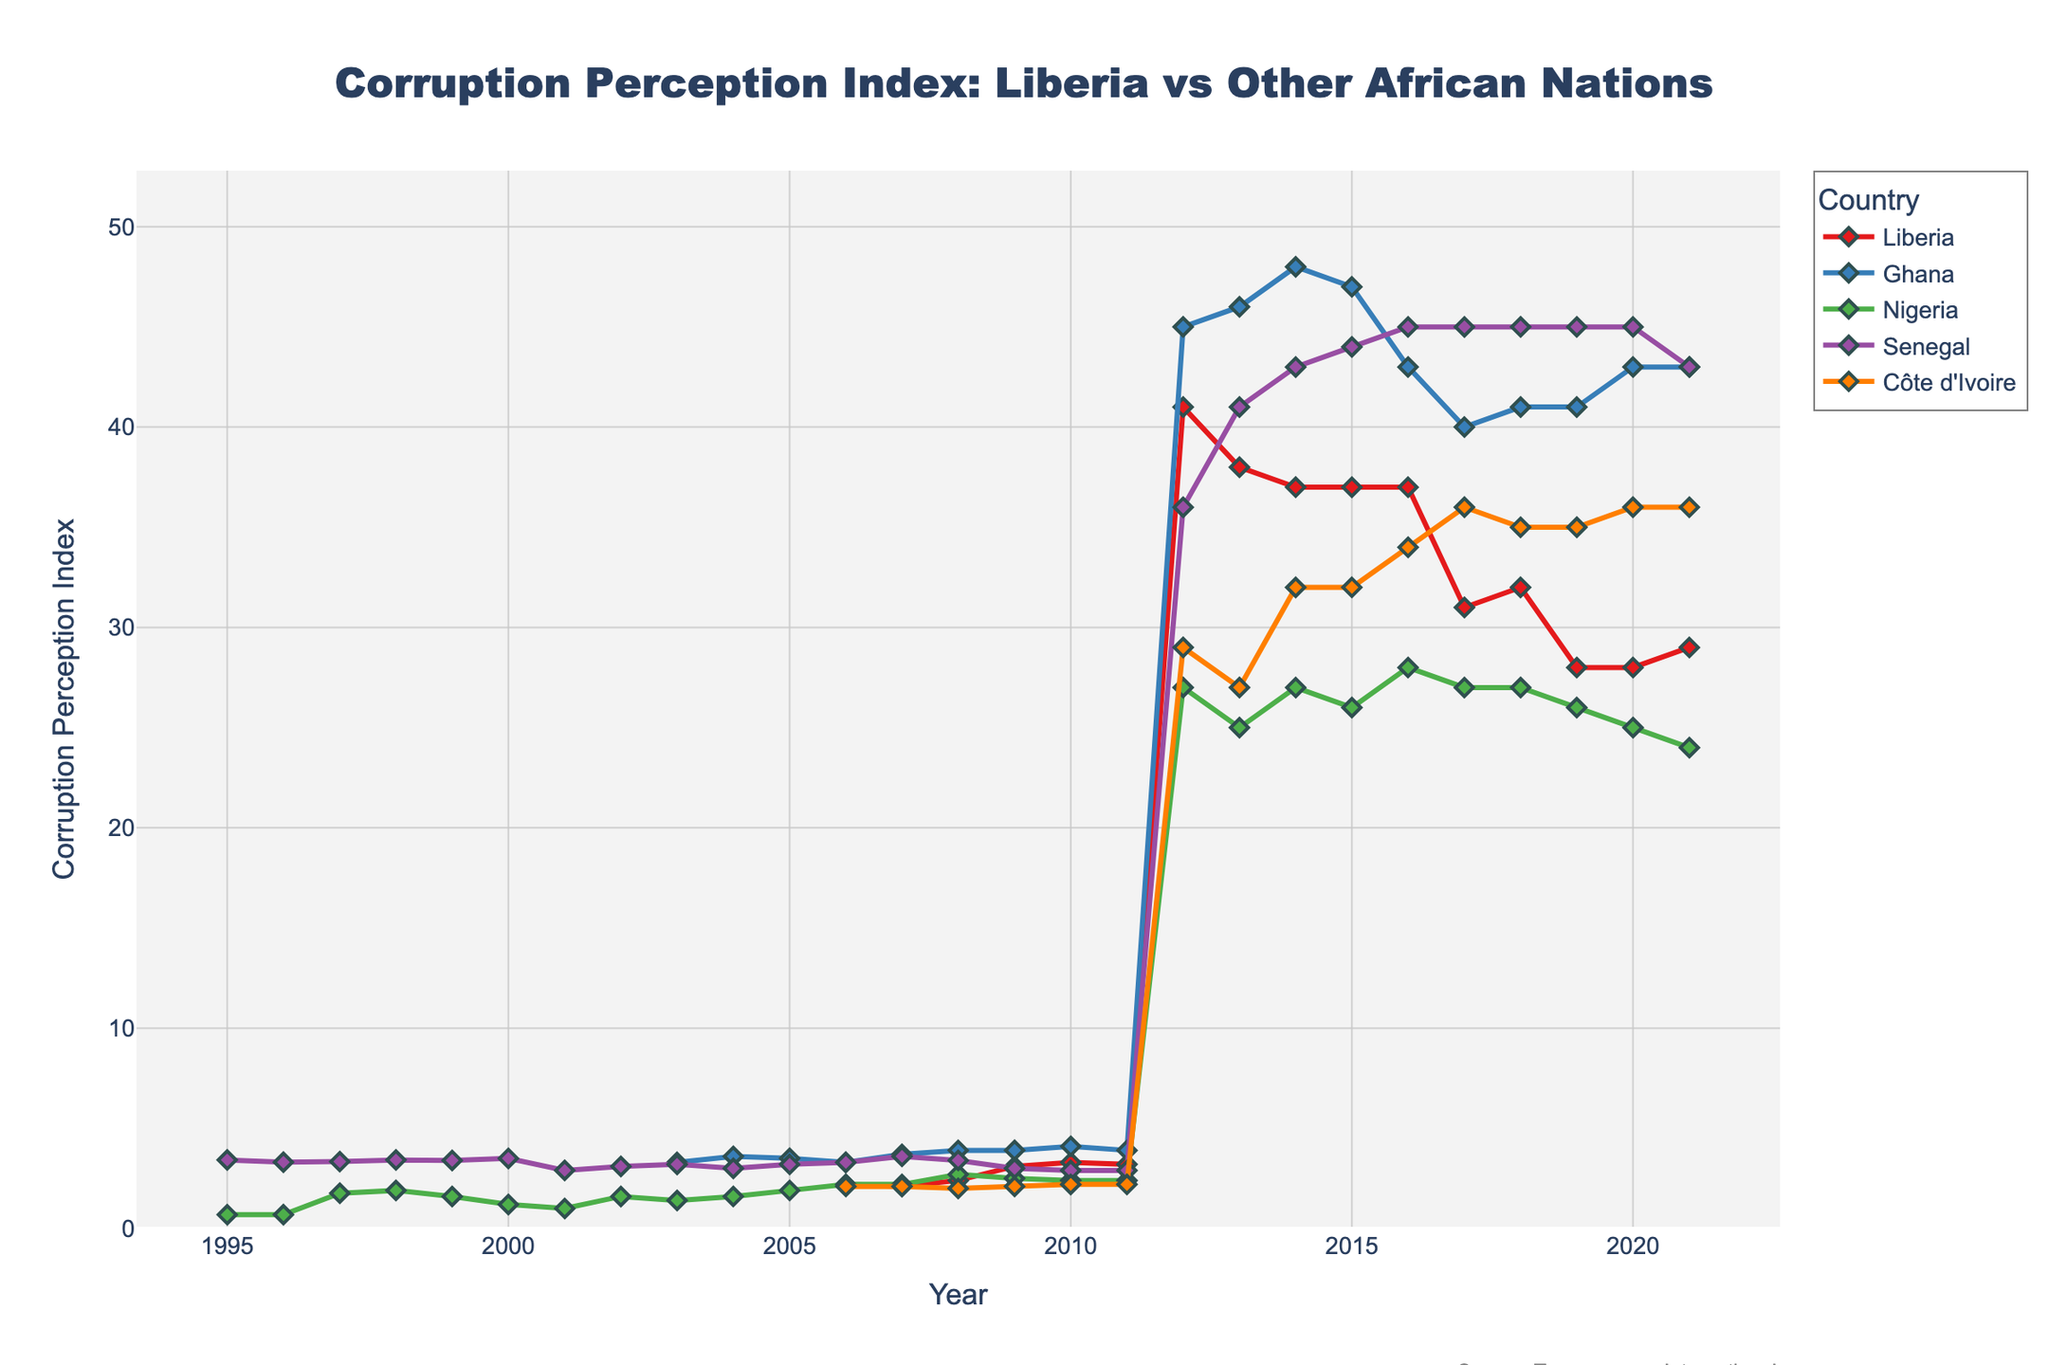what does the line representing Liberia's CPI look like before and after 2006? Before 2006, Liberia's CPI line does not exist, meaning no data points are available. After 2006, it starts appearing and reveals an increasing trend up to around 2009-2010, then fluctuates slightly before stabilizing.
Answer: Increasing trend after 2006 Which country has shown the most improvement in CPI since 2006? To determine this, we look at the overall trend of CPIs since 2006. Ghana shows the highest and most consistent rise in CPI values among the plotted countries, suggesting significant improvements in corruption perception.
Answer: Ghana Which country had the highest CPI in 2009? By referring to the data for 2009, we can see that Ghana had the highest CPI value among the countries visualized in the year 2009.
Answer: Ghana What general trend is observed for Liberia's CPI from 2012 onwards? From 2012 onwards, the dataset changes to a different format where higher numbers indicate lower corruption: Liberia's CPI starts around 41 and decreases to 29 by 2021, showing deterioration in corruption perception.
Answer: Deterioration Which two countries had similar CPI values in 2006? Comparing the CPI values for the year 2006, Liberia and Nigeria both had a CPI value of 2.2, indicating similar perceptions of corruption.
Answer: Liberia and Nigeria In which year did Côte d'Ivoire's CPI show a noticeable improvement after 2006? Observing the CPI values for Côte d'Ivoire after 2006, 2009 shows an improvement from 2.0 in 2008 to 2.1 in 2009. However, a more noticeable improvement occurs from 2011 onwards where values begin to rise steadily
Answer: 2011 Compare the trends of CPI for Nigeria and Senegal before and after 2012. Prior to 2012, Nigeria's CPI shows a slight increasing trend, whereas Senegal's remained relatively stable. After 2012, both countries' CPI data transformations indicate different trends, with Nigeria generally decreasing and Senegal rising then stabilizing around 45.
Answer: Nigeria decreased, Senegal rose Which country has the lowest CPI value in the most recent year shown, and what does it indicate? The most recent year in the dataset is 2021, where Nigeria has the lowest CPI value of 24, indicating the highest perceived level of corruption among the countries charted.
Answer: Nigeria What is the difference in CPI values between Ghana and Senegal in 2010? Referencing the CPI values for the year 2010: Ghana is at 4.1 and Senegal is at 2.9. The difference is 4.1 - 2.9.
Answer: 1.2 